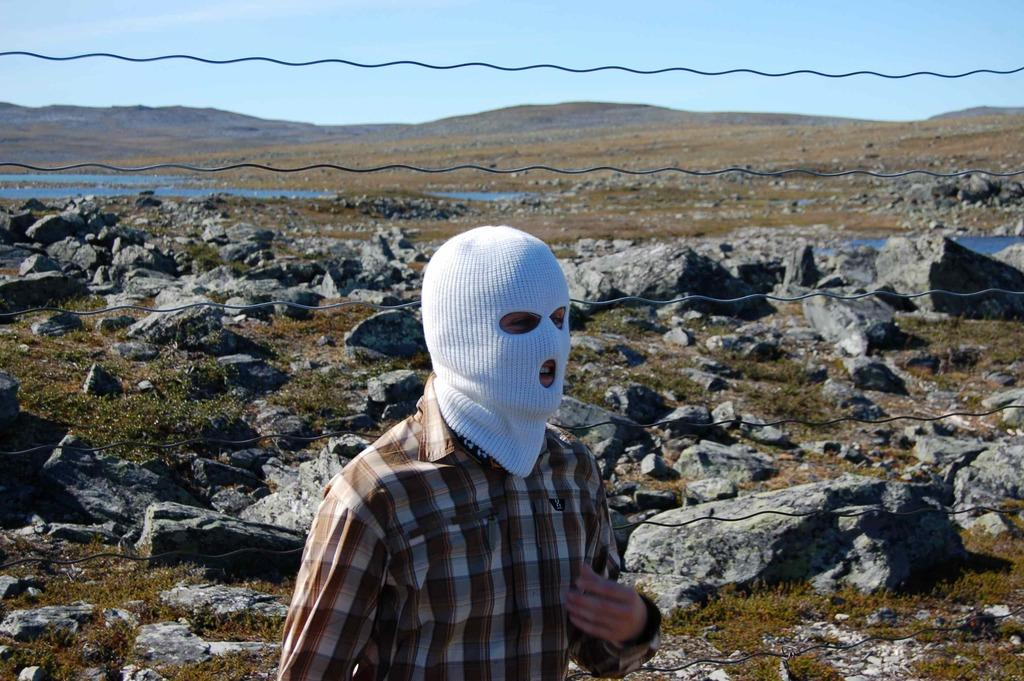Who is the main subject in the foreground of the image? There is a man standing in the foreground of the image. What is the man wearing on his face? The man is wearing a mask. What type of terrain is visible on the ground in the image? There are rocks on the ground in the image. What can be seen in the distance behind the man? The sky is visible in the background of the image. What color is the shirt the man is wearing in the image? The provided facts do not mention the man's shirt, so we cannot determine its color from the image. Can you tell me how many tubs are present in the image? There are no tubs visible in the image. 